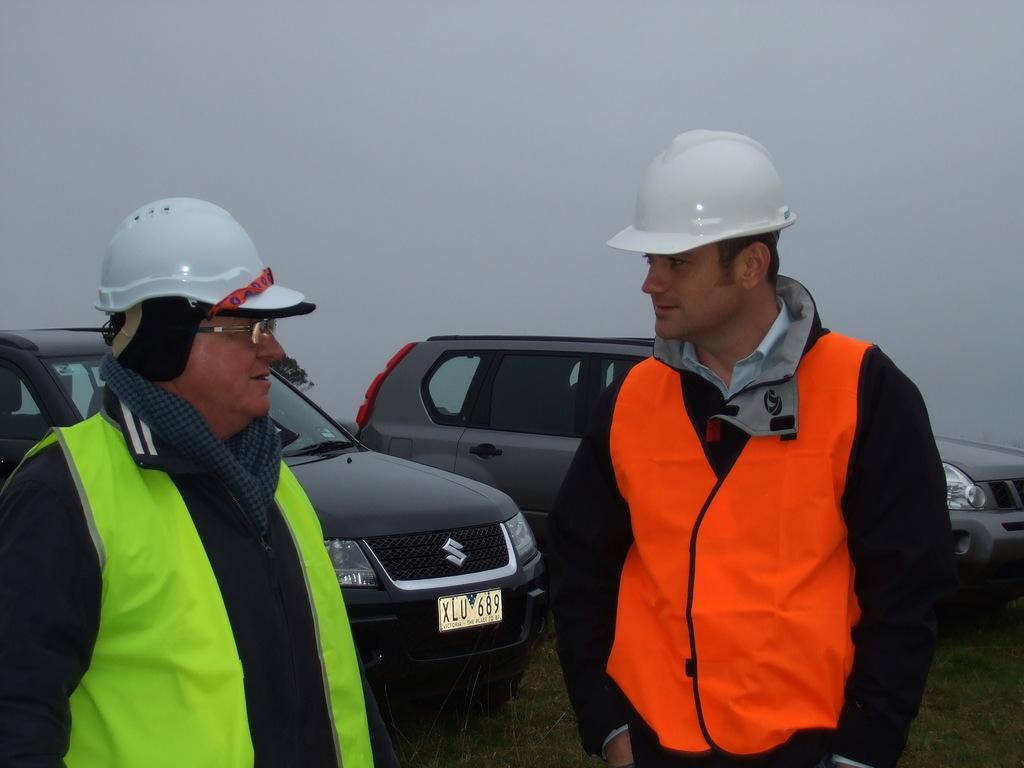Please provide a concise description of this image. This image consists of two men wearing helmets. On the right, the man is wearing an orange jacket. On the left, the man is wearing a green jacket. In the background, there are two cars. At the top, there is sky. At the bottom, there is green grass on the ground. 